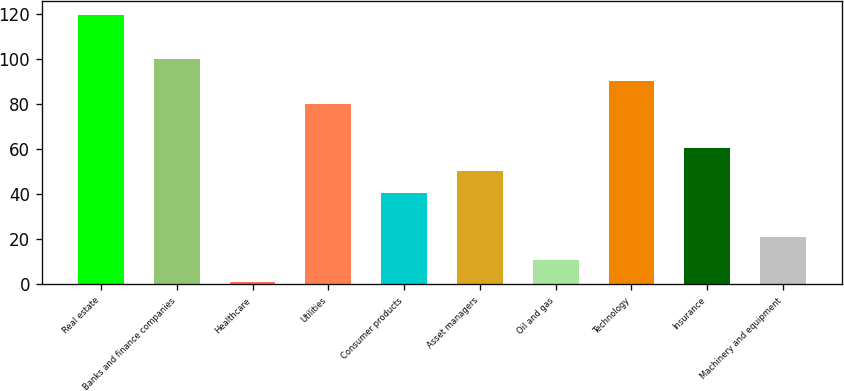<chart> <loc_0><loc_0><loc_500><loc_500><bar_chart><fcel>Real estate<fcel>Banks and finance companies<fcel>Healthcare<fcel>Utilities<fcel>Consumer products<fcel>Asset managers<fcel>Oil and gas<fcel>Technology<fcel>Insurance<fcel>Machinery and equipment<nl><fcel>119.8<fcel>100<fcel>1<fcel>80.2<fcel>40.6<fcel>50.5<fcel>10.9<fcel>90.1<fcel>60.4<fcel>20.8<nl></chart> 